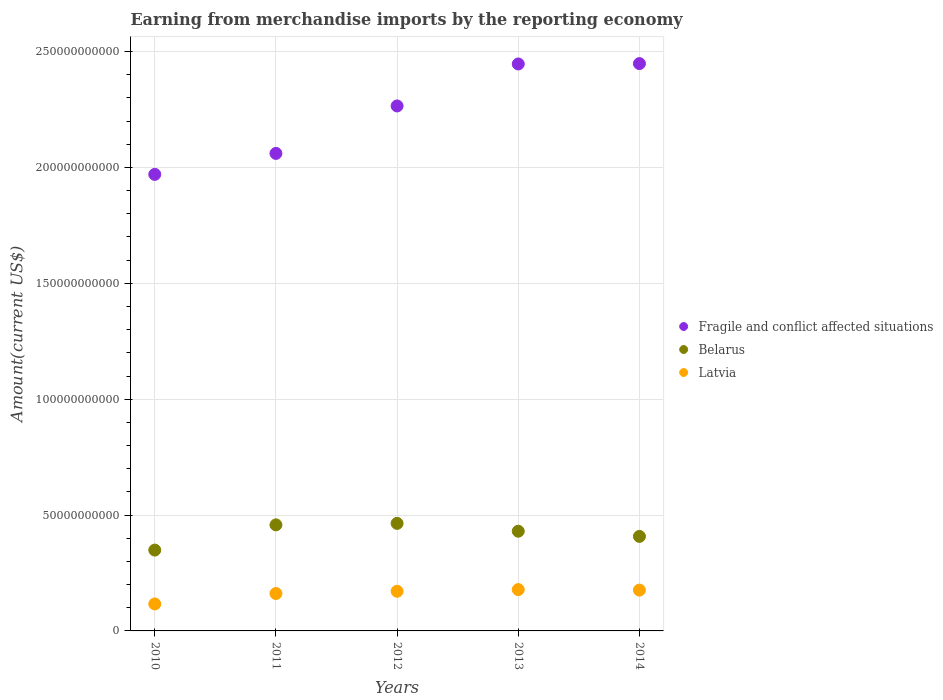How many different coloured dotlines are there?
Ensure brevity in your answer.  3. Is the number of dotlines equal to the number of legend labels?
Ensure brevity in your answer.  Yes. What is the amount earned from merchandise imports in Fragile and conflict affected situations in 2013?
Ensure brevity in your answer.  2.45e+11. Across all years, what is the maximum amount earned from merchandise imports in Belarus?
Keep it short and to the point. 4.64e+1. Across all years, what is the minimum amount earned from merchandise imports in Latvia?
Provide a short and direct response. 1.16e+1. In which year was the amount earned from merchandise imports in Latvia maximum?
Give a very brief answer. 2013. What is the total amount earned from merchandise imports in Belarus in the graph?
Your response must be concise. 2.11e+11. What is the difference between the amount earned from merchandise imports in Latvia in 2012 and that in 2013?
Provide a short and direct response. -7.25e+08. What is the difference between the amount earned from merchandise imports in Fragile and conflict affected situations in 2011 and the amount earned from merchandise imports in Belarus in 2014?
Keep it short and to the point. 1.65e+11. What is the average amount earned from merchandise imports in Belarus per year?
Your answer should be very brief. 4.22e+1. In the year 2010, what is the difference between the amount earned from merchandise imports in Belarus and amount earned from merchandise imports in Fragile and conflict affected situations?
Keep it short and to the point. -1.62e+11. What is the ratio of the amount earned from merchandise imports in Fragile and conflict affected situations in 2010 to that in 2014?
Keep it short and to the point. 0.8. What is the difference between the highest and the second highest amount earned from merchandise imports in Latvia?
Give a very brief answer. 2.20e+08. What is the difference between the highest and the lowest amount earned from merchandise imports in Fragile and conflict affected situations?
Provide a short and direct response. 4.78e+1. In how many years, is the amount earned from merchandise imports in Fragile and conflict affected situations greater than the average amount earned from merchandise imports in Fragile and conflict affected situations taken over all years?
Keep it short and to the point. 3. Is it the case that in every year, the sum of the amount earned from merchandise imports in Latvia and amount earned from merchandise imports in Fragile and conflict affected situations  is greater than the amount earned from merchandise imports in Belarus?
Ensure brevity in your answer.  Yes. Is the amount earned from merchandise imports in Belarus strictly greater than the amount earned from merchandise imports in Latvia over the years?
Your answer should be very brief. Yes. Is the amount earned from merchandise imports in Belarus strictly less than the amount earned from merchandise imports in Fragile and conflict affected situations over the years?
Make the answer very short. Yes. How many dotlines are there?
Make the answer very short. 3. What is the difference between two consecutive major ticks on the Y-axis?
Keep it short and to the point. 5.00e+1. Does the graph contain grids?
Keep it short and to the point. Yes. Where does the legend appear in the graph?
Your answer should be compact. Center right. How many legend labels are there?
Your response must be concise. 3. What is the title of the graph?
Provide a succinct answer. Earning from merchandise imports by the reporting economy. Does "Small states" appear as one of the legend labels in the graph?
Provide a succinct answer. No. What is the label or title of the X-axis?
Ensure brevity in your answer.  Years. What is the label or title of the Y-axis?
Keep it short and to the point. Amount(current US$). What is the Amount(current US$) in Fragile and conflict affected situations in 2010?
Provide a succinct answer. 1.97e+11. What is the Amount(current US$) of Belarus in 2010?
Your response must be concise. 3.49e+1. What is the Amount(current US$) of Latvia in 2010?
Provide a succinct answer. 1.16e+1. What is the Amount(current US$) in Fragile and conflict affected situations in 2011?
Offer a very short reply. 2.06e+11. What is the Amount(current US$) in Belarus in 2011?
Ensure brevity in your answer.  4.58e+1. What is the Amount(current US$) of Latvia in 2011?
Your answer should be compact. 1.61e+1. What is the Amount(current US$) of Fragile and conflict affected situations in 2012?
Provide a short and direct response. 2.27e+11. What is the Amount(current US$) in Belarus in 2012?
Provide a succinct answer. 4.64e+1. What is the Amount(current US$) of Latvia in 2012?
Your response must be concise. 1.71e+1. What is the Amount(current US$) in Fragile and conflict affected situations in 2013?
Keep it short and to the point. 2.45e+11. What is the Amount(current US$) in Belarus in 2013?
Your answer should be very brief. 4.30e+1. What is the Amount(current US$) of Latvia in 2013?
Give a very brief answer. 1.78e+1. What is the Amount(current US$) of Fragile and conflict affected situations in 2014?
Offer a very short reply. 2.45e+11. What is the Amount(current US$) in Belarus in 2014?
Your answer should be very brief. 4.08e+1. What is the Amount(current US$) in Latvia in 2014?
Your response must be concise. 1.76e+1. Across all years, what is the maximum Amount(current US$) of Fragile and conflict affected situations?
Offer a very short reply. 2.45e+11. Across all years, what is the maximum Amount(current US$) of Belarus?
Ensure brevity in your answer.  4.64e+1. Across all years, what is the maximum Amount(current US$) of Latvia?
Give a very brief answer. 1.78e+1. Across all years, what is the minimum Amount(current US$) in Fragile and conflict affected situations?
Your answer should be compact. 1.97e+11. Across all years, what is the minimum Amount(current US$) in Belarus?
Your response must be concise. 3.49e+1. Across all years, what is the minimum Amount(current US$) of Latvia?
Provide a succinct answer. 1.16e+1. What is the total Amount(current US$) in Fragile and conflict affected situations in the graph?
Offer a terse response. 1.12e+12. What is the total Amount(current US$) of Belarus in the graph?
Make the answer very short. 2.11e+11. What is the total Amount(current US$) in Latvia in the graph?
Provide a short and direct response. 8.03e+1. What is the difference between the Amount(current US$) of Fragile and conflict affected situations in 2010 and that in 2011?
Make the answer very short. -9.05e+09. What is the difference between the Amount(current US$) in Belarus in 2010 and that in 2011?
Make the answer very short. -1.09e+1. What is the difference between the Amount(current US$) in Latvia in 2010 and that in 2011?
Offer a very short reply. -4.50e+09. What is the difference between the Amount(current US$) of Fragile and conflict affected situations in 2010 and that in 2012?
Your answer should be compact. -2.95e+1. What is the difference between the Amount(current US$) of Belarus in 2010 and that in 2012?
Offer a terse response. -1.15e+1. What is the difference between the Amount(current US$) in Latvia in 2010 and that in 2012?
Give a very brief answer. -5.47e+09. What is the difference between the Amount(current US$) in Fragile and conflict affected situations in 2010 and that in 2013?
Make the answer very short. -4.76e+1. What is the difference between the Amount(current US$) in Belarus in 2010 and that in 2013?
Your answer should be very brief. -8.14e+09. What is the difference between the Amount(current US$) of Latvia in 2010 and that in 2013?
Offer a very short reply. -6.19e+09. What is the difference between the Amount(current US$) of Fragile and conflict affected situations in 2010 and that in 2014?
Your answer should be compact. -4.78e+1. What is the difference between the Amount(current US$) in Belarus in 2010 and that in 2014?
Give a very brief answer. -5.90e+09. What is the difference between the Amount(current US$) of Latvia in 2010 and that in 2014?
Your answer should be compact. -5.97e+09. What is the difference between the Amount(current US$) of Fragile and conflict affected situations in 2011 and that in 2012?
Provide a succinct answer. -2.05e+1. What is the difference between the Amount(current US$) in Belarus in 2011 and that in 2012?
Offer a terse response. -6.45e+08. What is the difference between the Amount(current US$) in Latvia in 2011 and that in 2012?
Keep it short and to the point. -9.66e+08. What is the difference between the Amount(current US$) in Fragile and conflict affected situations in 2011 and that in 2013?
Make the answer very short. -3.86e+1. What is the difference between the Amount(current US$) in Belarus in 2011 and that in 2013?
Make the answer very short. 2.74e+09. What is the difference between the Amount(current US$) of Latvia in 2011 and that in 2013?
Give a very brief answer. -1.69e+09. What is the difference between the Amount(current US$) in Fragile and conflict affected situations in 2011 and that in 2014?
Give a very brief answer. -3.88e+1. What is the difference between the Amount(current US$) in Belarus in 2011 and that in 2014?
Make the answer very short. 4.97e+09. What is the difference between the Amount(current US$) in Latvia in 2011 and that in 2014?
Your answer should be compact. -1.47e+09. What is the difference between the Amount(current US$) of Fragile and conflict affected situations in 2012 and that in 2013?
Offer a very short reply. -1.81e+1. What is the difference between the Amount(current US$) in Belarus in 2012 and that in 2013?
Your response must be concise. 3.38e+09. What is the difference between the Amount(current US$) of Latvia in 2012 and that in 2013?
Your answer should be very brief. -7.25e+08. What is the difference between the Amount(current US$) in Fragile and conflict affected situations in 2012 and that in 2014?
Keep it short and to the point. -1.83e+1. What is the difference between the Amount(current US$) of Belarus in 2012 and that in 2014?
Your answer should be compact. 5.62e+09. What is the difference between the Amount(current US$) of Latvia in 2012 and that in 2014?
Your response must be concise. -5.05e+08. What is the difference between the Amount(current US$) in Fragile and conflict affected situations in 2013 and that in 2014?
Your response must be concise. -1.66e+08. What is the difference between the Amount(current US$) of Belarus in 2013 and that in 2014?
Provide a succinct answer. 2.23e+09. What is the difference between the Amount(current US$) of Latvia in 2013 and that in 2014?
Keep it short and to the point. 2.20e+08. What is the difference between the Amount(current US$) of Fragile and conflict affected situations in 2010 and the Amount(current US$) of Belarus in 2011?
Provide a short and direct response. 1.51e+11. What is the difference between the Amount(current US$) in Fragile and conflict affected situations in 2010 and the Amount(current US$) in Latvia in 2011?
Keep it short and to the point. 1.81e+11. What is the difference between the Amount(current US$) in Belarus in 2010 and the Amount(current US$) in Latvia in 2011?
Provide a succinct answer. 1.87e+1. What is the difference between the Amount(current US$) in Fragile and conflict affected situations in 2010 and the Amount(current US$) in Belarus in 2012?
Your answer should be very brief. 1.51e+11. What is the difference between the Amount(current US$) of Fragile and conflict affected situations in 2010 and the Amount(current US$) of Latvia in 2012?
Give a very brief answer. 1.80e+11. What is the difference between the Amount(current US$) in Belarus in 2010 and the Amount(current US$) in Latvia in 2012?
Provide a short and direct response. 1.78e+1. What is the difference between the Amount(current US$) in Fragile and conflict affected situations in 2010 and the Amount(current US$) in Belarus in 2013?
Offer a terse response. 1.54e+11. What is the difference between the Amount(current US$) of Fragile and conflict affected situations in 2010 and the Amount(current US$) of Latvia in 2013?
Provide a short and direct response. 1.79e+11. What is the difference between the Amount(current US$) of Belarus in 2010 and the Amount(current US$) of Latvia in 2013?
Ensure brevity in your answer.  1.71e+1. What is the difference between the Amount(current US$) of Fragile and conflict affected situations in 2010 and the Amount(current US$) of Belarus in 2014?
Ensure brevity in your answer.  1.56e+11. What is the difference between the Amount(current US$) of Fragile and conflict affected situations in 2010 and the Amount(current US$) of Latvia in 2014?
Keep it short and to the point. 1.79e+11. What is the difference between the Amount(current US$) of Belarus in 2010 and the Amount(current US$) of Latvia in 2014?
Provide a short and direct response. 1.73e+1. What is the difference between the Amount(current US$) in Fragile and conflict affected situations in 2011 and the Amount(current US$) in Belarus in 2012?
Your answer should be compact. 1.60e+11. What is the difference between the Amount(current US$) in Fragile and conflict affected situations in 2011 and the Amount(current US$) in Latvia in 2012?
Provide a succinct answer. 1.89e+11. What is the difference between the Amount(current US$) of Belarus in 2011 and the Amount(current US$) of Latvia in 2012?
Offer a very short reply. 2.87e+1. What is the difference between the Amount(current US$) of Fragile and conflict affected situations in 2011 and the Amount(current US$) of Belarus in 2013?
Your answer should be very brief. 1.63e+11. What is the difference between the Amount(current US$) in Fragile and conflict affected situations in 2011 and the Amount(current US$) in Latvia in 2013?
Your response must be concise. 1.88e+11. What is the difference between the Amount(current US$) of Belarus in 2011 and the Amount(current US$) of Latvia in 2013?
Your response must be concise. 2.79e+1. What is the difference between the Amount(current US$) of Fragile and conflict affected situations in 2011 and the Amount(current US$) of Belarus in 2014?
Keep it short and to the point. 1.65e+11. What is the difference between the Amount(current US$) in Fragile and conflict affected situations in 2011 and the Amount(current US$) in Latvia in 2014?
Provide a short and direct response. 1.88e+11. What is the difference between the Amount(current US$) in Belarus in 2011 and the Amount(current US$) in Latvia in 2014?
Keep it short and to the point. 2.81e+1. What is the difference between the Amount(current US$) of Fragile and conflict affected situations in 2012 and the Amount(current US$) of Belarus in 2013?
Offer a terse response. 1.84e+11. What is the difference between the Amount(current US$) of Fragile and conflict affected situations in 2012 and the Amount(current US$) of Latvia in 2013?
Give a very brief answer. 2.09e+11. What is the difference between the Amount(current US$) in Belarus in 2012 and the Amount(current US$) in Latvia in 2013?
Make the answer very short. 2.86e+1. What is the difference between the Amount(current US$) in Fragile and conflict affected situations in 2012 and the Amount(current US$) in Belarus in 2014?
Your response must be concise. 1.86e+11. What is the difference between the Amount(current US$) of Fragile and conflict affected situations in 2012 and the Amount(current US$) of Latvia in 2014?
Your response must be concise. 2.09e+11. What is the difference between the Amount(current US$) of Belarus in 2012 and the Amount(current US$) of Latvia in 2014?
Your answer should be very brief. 2.88e+1. What is the difference between the Amount(current US$) of Fragile and conflict affected situations in 2013 and the Amount(current US$) of Belarus in 2014?
Your response must be concise. 2.04e+11. What is the difference between the Amount(current US$) in Fragile and conflict affected situations in 2013 and the Amount(current US$) in Latvia in 2014?
Provide a short and direct response. 2.27e+11. What is the difference between the Amount(current US$) in Belarus in 2013 and the Amount(current US$) in Latvia in 2014?
Provide a succinct answer. 2.54e+1. What is the average Amount(current US$) in Fragile and conflict affected situations per year?
Keep it short and to the point. 2.24e+11. What is the average Amount(current US$) of Belarus per year?
Your answer should be very brief. 4.22e+1. What is the average Amount(current US$) of Latvia per year?
Give a very brief answer. 1.61e+1. In the year 2010, what is the difference between the Amount(current US$) in Fragile and conflict affected situations and Amount(current US$) in Belarus?
Offer a very short reply. 1.62e+11. In the year 2010, what is the difference between the Amount(current US$) of Fragile and conflict affected situations and Amount(current US$) of Latvia?
Make the answer very short. 1.85e+11. In the year 2010, what is the difference between the Amount(current US$) in Belarus and Amount(current US$) in Latvia?
Offer a very short reply. 2.32e+1. In the year 2011, what is the difference between the Amount(current US$) in Fragile and conflict affected situations and Amount(current US$) in Belarus?
Ensure brevity in your answer.  1.60e+11. In the year 2011, what is the difference between the Amount(current US$) in Fragile and conflict affected situations and Amount(current US$) in Latvia?
Provide a succinct answer. 1.90e+11. In the year 2011, what is the difference between the Amount(current US$) of Belarus and Amount(current US$) of Latvia?
Your answer should be very brief. 2.96e+1. In the year 2012, what is the difference between the Amount(current US$) in Fragile and conflict affected situations and Amount(current US$) in Belarus?
Your answer should be compact. 1.80e+11. In the year 2012, what is the difference between the Amount(current US$) in Fragile and conflict affected situations and Amount(current US$) in Latvia?
Ensure brevity in your answer.  2.09e+11. In the year 2012, what is the difference between the Amount(current US$) of Belarus and Amount(current US$) of Latvia?
Your response must be concise. 2.93e+1. In the year 2013, what is the difference between the Amount(current US$) of Fragile and conflict affected situations and Amount(current US$) of Belarus?
Your answer should be very brief. 2.02e+11. In the year 2013, what is the difference between the Amount(current US$) of Fragile and conflict affected situations and Amount(current US$) of Latvia?
Ensure brevity in your answer.  2.27e+11. In the year 2013, what is the difference between the Amount(current US$) of Belarus and Amount(current US$) of Latvia?
Your answer should be compact. 2.52e+1. In the year 2014, what is the difference between the Amount(current US$) in Fragile and conflict affected situations and Amount(current US$) in Belarus?
Give a very brief answer. 2.04e+11. In the year 2014, what is the difference between the Amount(current US$) of Fragile and conflict affected situations and Amount(current US$) of Latvia?
Your response must be concise. 2.27e+11. In the year 2014, what is the difference between the Amount(current US$) of Belarus and Amount(current US$) of Latvia?
Provide a short and direct response. 2.32e+1. What is the ratio of the Amount(current US$) in Fragile and conflict affected situations in 2010 to that in 2011?
Provide a short and direct response. 0.96. What is the ratio of the Amount(current US$) of Belarus in 2010 to that in 2011?
Give a very brief answer. 0.76. What is the ratio of the Amount(current US$) of Latvia in 2010 to that in 2011?
Provide a succinct answer. 0.72. What is the ratio of the Amount(current US$) in Fragile and conflict affected situations in 2010 to that in 2012?
Give a very brief answer. 0.87. What is the ratio of the Amount(current US$) of Belarus in 2010 to that in 2012?
Offer a terse response. 0.75. What is the ratio of the Amount(current US$) of Latvia in 2010 to that in 2012?
Ensure brevity in your answer.  0.68. What is the ratio of the Amount(current US$) in Fragile and conflict affected situations in 2010 to that in 2013?
Offer a very short reply. 0.81. What is the ratio of the Amount(current US$) in Belarus in 2010 to that in 2013?
Provide a succinct answer. 0.81. What is the ratio of the Amount(current US$) in Latvia in 2010 to that in 2013?
Offer a very short reply. 0.65. What is the ratio of the Amount(current US$) in Fragile and conflict affected situations in 2010 to that in 2014?
Make the answer very short. 0.8. What is the ratio of the Amount(current US$) in Belarus in 2010 to that in 2014?
Offer a very short reply. 0.86. What is the ratio of the Amount(current US$) of Latvia in 2010 to that in 2014?
Ensure brevity in your answer.  0.66. What is the ratio of the Amount(current US$) of Fragile and conflict affected situations in 2011 to that in 2012?
Provide a succinct answer. 0.91. What is the ratio of the Amount(current US$) of Belarus in 2011 to that in 2012?
Keep it short and to the point. 0.99. What is the ratio of the Amount(current US$) in Latvia in 2011 to that in 2012?
Your answer should be very brief. 0.94. What is the ratio of the Amount(current US$) of Fragile and conflict affected situations in 2011 to that in 2013?
Provide a short and direct response. 0.84. What is the ratio of the Amount(current US$) in Belarus in 2011 to that in 2013?
Give a very brief answer. 1.06. What is the ratio of the Amount(current US$) in Latvia in 2011 to that in 2013?
Make the answer very short. 0.91. What is the ratio of the Amount(current US$) of Fragile and conflict affected situations in 2011 to that in 2014?
Provide a succinct answer. 0.84. What is the ratio of the Amount(current US$) of Belarus in 2011 to that in 2014?
Offer a very short reply. 1.12. What is the ratio of the Amount(current US$) of Latvia in 2011 to that in 2014?
Your response must be concise. 0.92. What is the ratio of the Amount(current US$) of Fragile and conflict affected situations in 2012 to that in 2013?
Provide a succinct answer. 0.93. What is the ratio of the Amount(current US$) of Belarus in 2012 to that in 2013?
Offer a very short reply. 1.08. What is the ratio of the Amount(current US$) of Latvia in 2012 to that in 2013?
Offer a terse response. 0.96. What is the ratio of the Amount(current US$) in Fragile and conflict affected situations in 2012 to that in 2014?
Ensure brevity in your answer.  0.93. What is the ratio of the Amount(current US$) of Belarus in 2012 to that in 2014?
Your answer should be very brief. 1.14. What is the ratio of the Amount(current US$) of Latvia in 2012 to that in 2014?
Your answer should be very brief. 0.97. What is the ratio of the Amount(current US$) of Fragile and conflict affected situations in 2013 to that in 2014?
Give a very brief answer. 1. What is the ratio of the Amount(current US$) of Belarus in 2013 to that in 2014?
Ensure brevity in your answer.  1.05. What is the ratio of the Amount(current US$) of Latvia in 2013 to that in 2014?
Provide a succinct answer. 1.01. What is the difference between the highest and the second highest Amount(current US$) of Fragile and conflict affected situations?
Provide a short and direct response. 1.66e+08. What is the difference between the highest and the second highest Amount(current US$) of Belarus?
Provide a short and direct response. 6.45e+08. What is the difference between the highest and the second highest Amount(current US$) in Latvia?
Your answer should be compact. 2.20e+08. What is the difference between the highest and the lowest Amount(current US$) in Fragile and conflict affected situations?
Make the answer very short. 4.78e+1. What is the difference between the highest and the lowest Amount(current US$) of Belarus?
Offer a very short reply. 1.15e+1. What is the difference between the highest and the lowest Amount(current US$) in Latvia?
Give a very brief answer. 6.19e+09. 